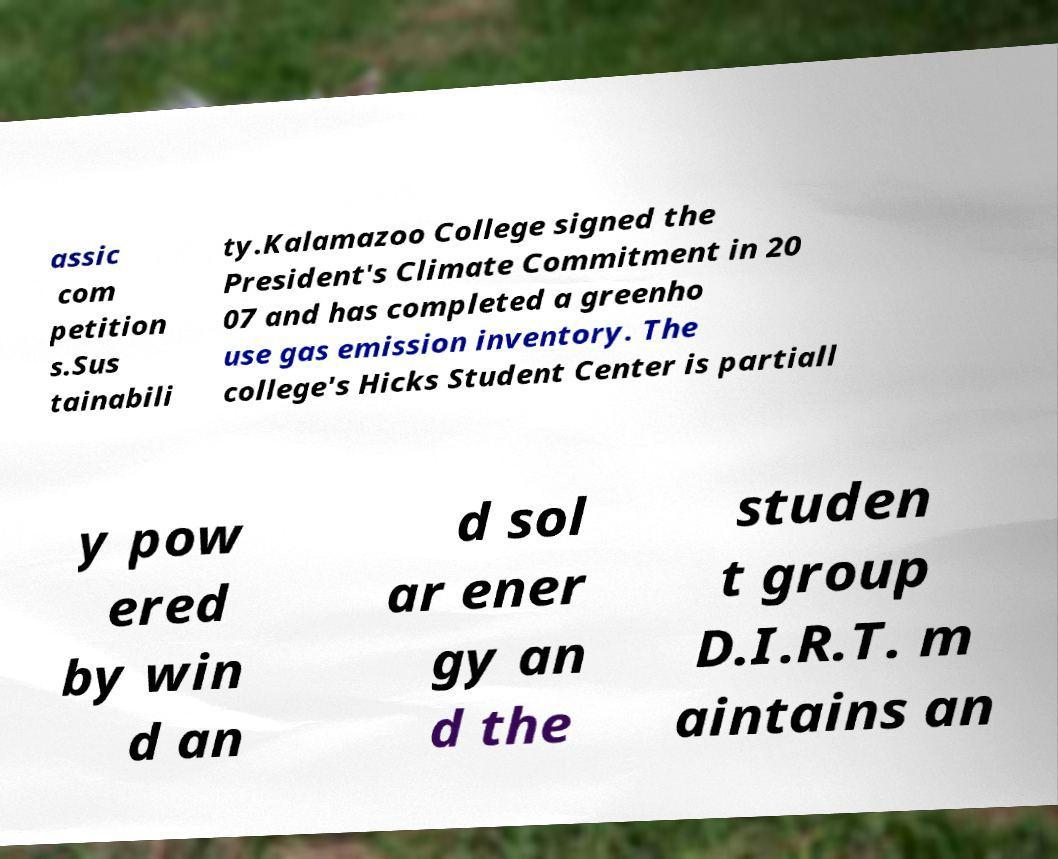Please read and relay the text visible in this image. What does it say? assic com petition s.Sus tainabili ty.Kalamazoo College signed the President's Climate Commitment in 20 07 and has completed a greenho use gas emission inventory. The college's Hicks Student Center is partiall y pow ered by win d an d sol ar ener gy an d the studen t group D.I.R.T. m aintains an 